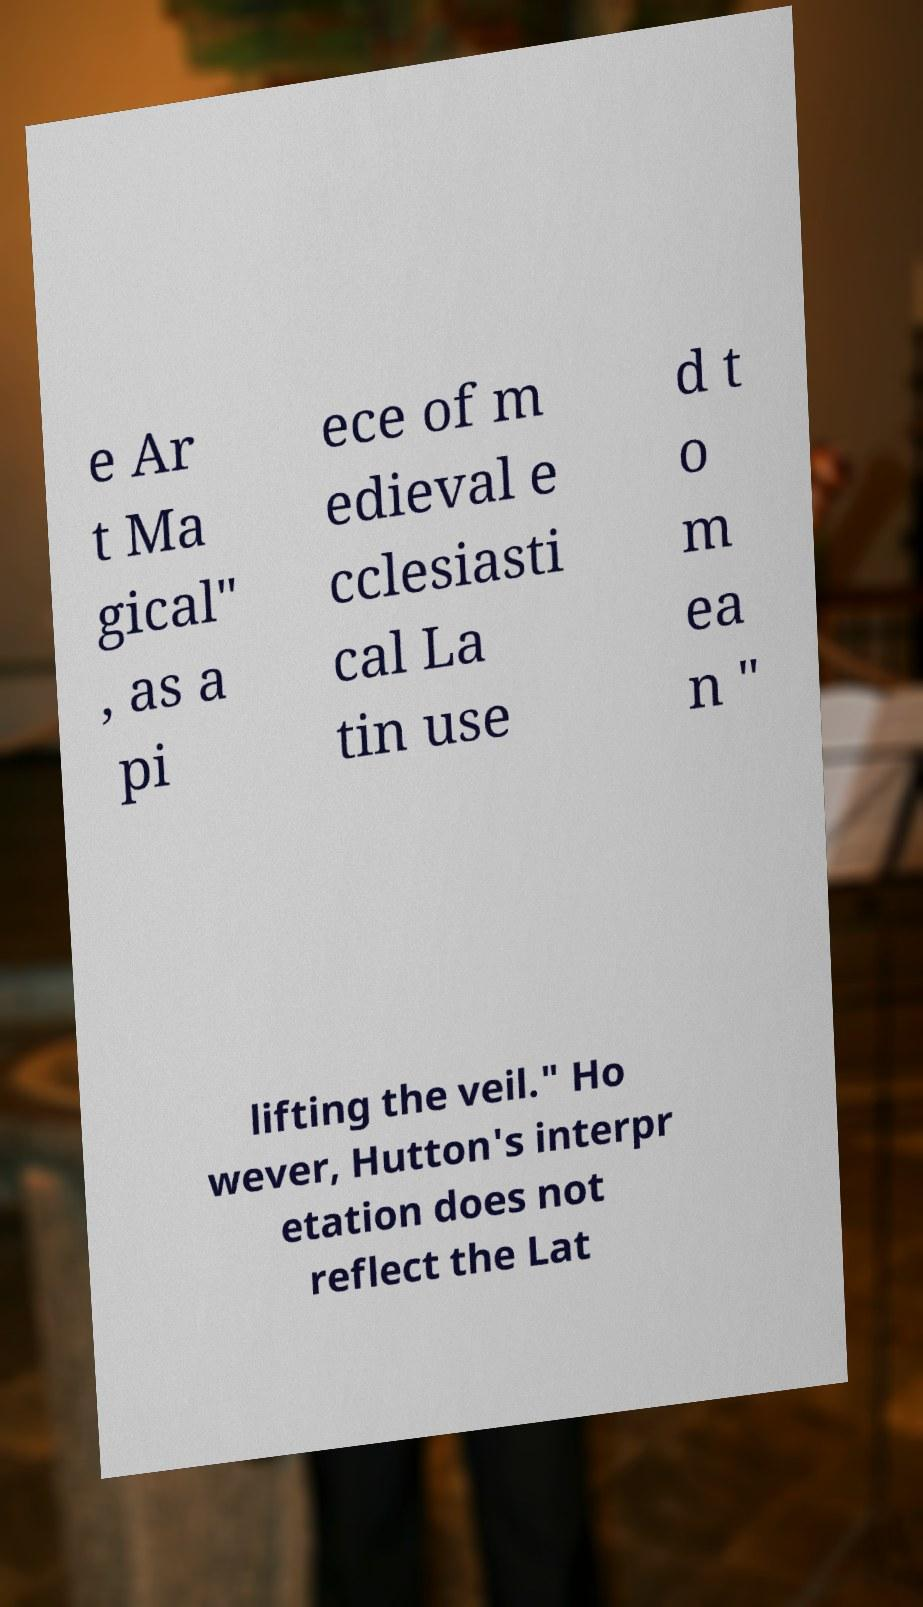There's text embedded in this image that I need extracted. Can you transcribe it verbatim? e Ar t Ma gical" , as a pi ece of m edieval e cclesiasti cal La tin use d t o m ea n " lifting the veil." Ho wever, Hutton's interpr etation does not reflect the Lat 